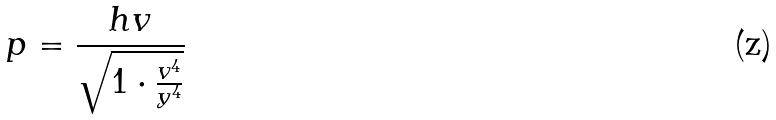Convert formula to latex. <formula><loc_0><loc_0><loc_500><loc_500>p = \frac { h v } { \sqrt { 1 \cdot \frac { v ^ { 4 } } { y ^ { 4 } } } }</formula> 